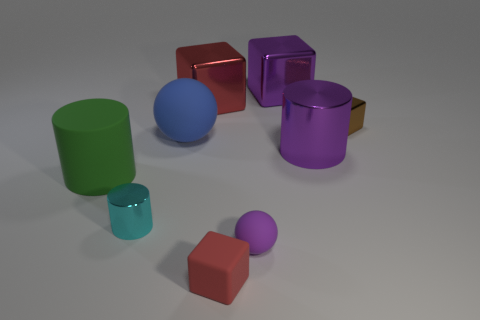Subtract all blocks. How many objects are left? 5 Add 9 big blue matte objects. How many big blue matte objects are left? 10 Add 9 rubber cubes. How many rubber cubes exist? 10 Subtract 1 blue spheres. How many objects are left? 8 Subtract all small spheres. Subtract all tiny brown matte objects. How many objects are left? 8 